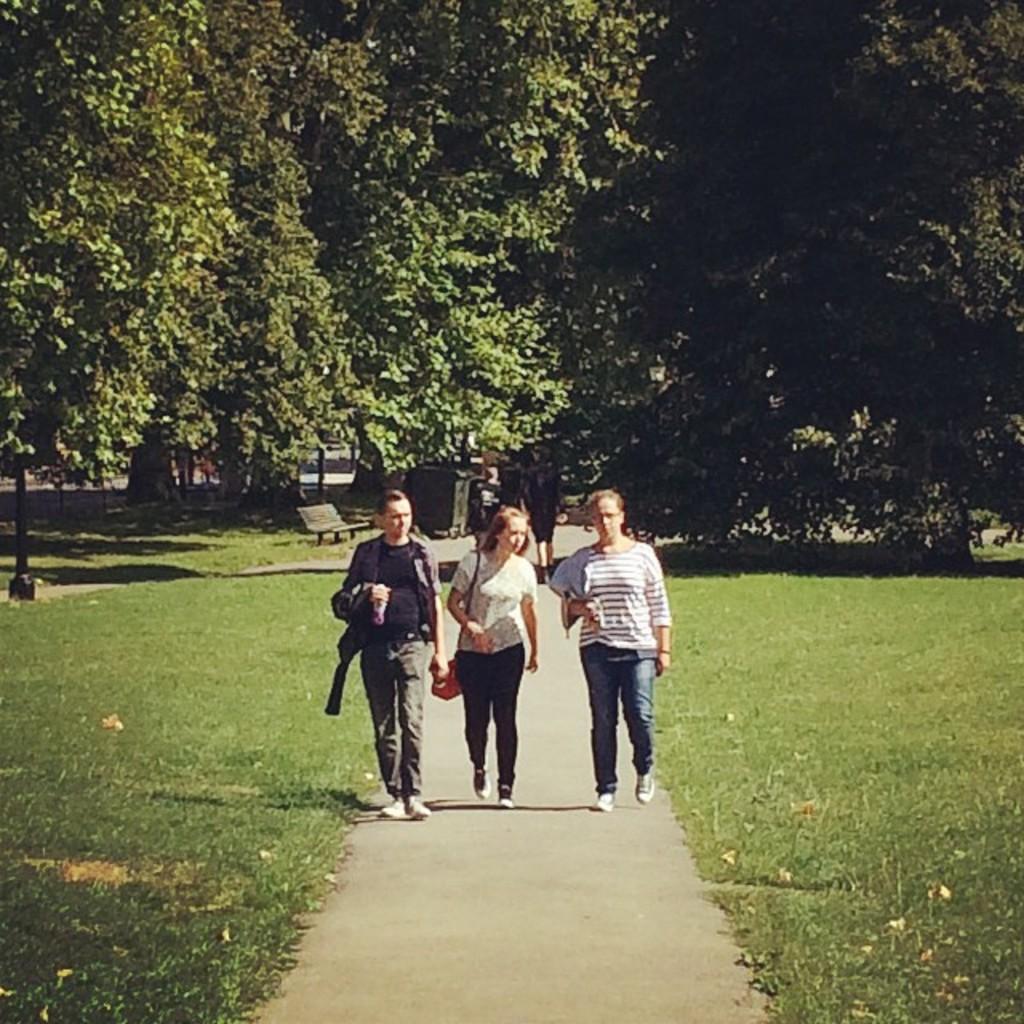How would you summarize this image in a sentence or two? In this image I can see three persons walking. In the background I can see the bench and few trees in green color. 